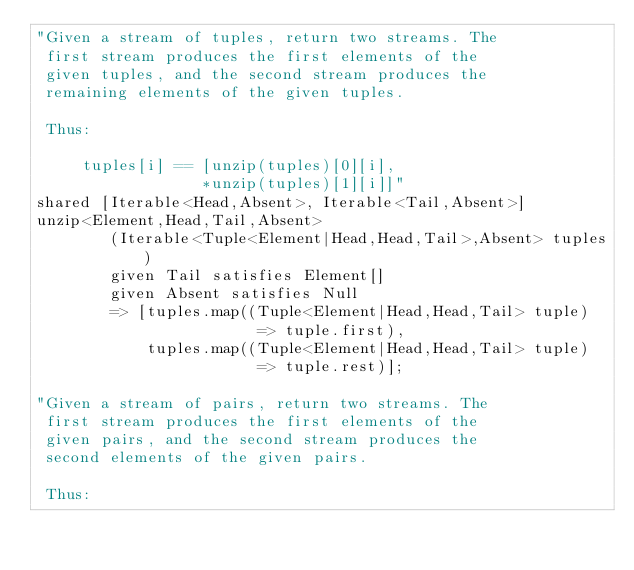<code> <loc_0><loc_0><loc_500><loc_500><_Ceylon_>"Given a stream of tuples, return two streams. The
 first stream produces the first elements of the
 given tuples, and the second stream produces the
 remaining elements of the given tuples.
 
 Thus:
 
     tuples[i] == [unzip(tuples)[0][i], 
                  *unzip(tuples)[1][i]]"
shared [Iterable<Head,Absent>, Iterable<Tail,Absent>] 
unzip<Element,Head,Tail,Absent>
        (Iterable<Tuple<Element|Head,Head,Tail>,Absent> tuples)
        given Tail satisfies Element[]
        given Absent satisfies Null
        => [tuples.map((Tuple<Element|Head,Head,Tail> tuple) 
                        => tuple.first),
            tuples.map((Tuple<Element|Head,Head,Tail> tuple) 
                        => tuple.rest)];

"Given a stream of pairs, return two streams. The
 first stream produces the first elements of the
 given pairs, and the second stream produces the
 second elements of the given pairs.
 
 Thus:
 </code> 